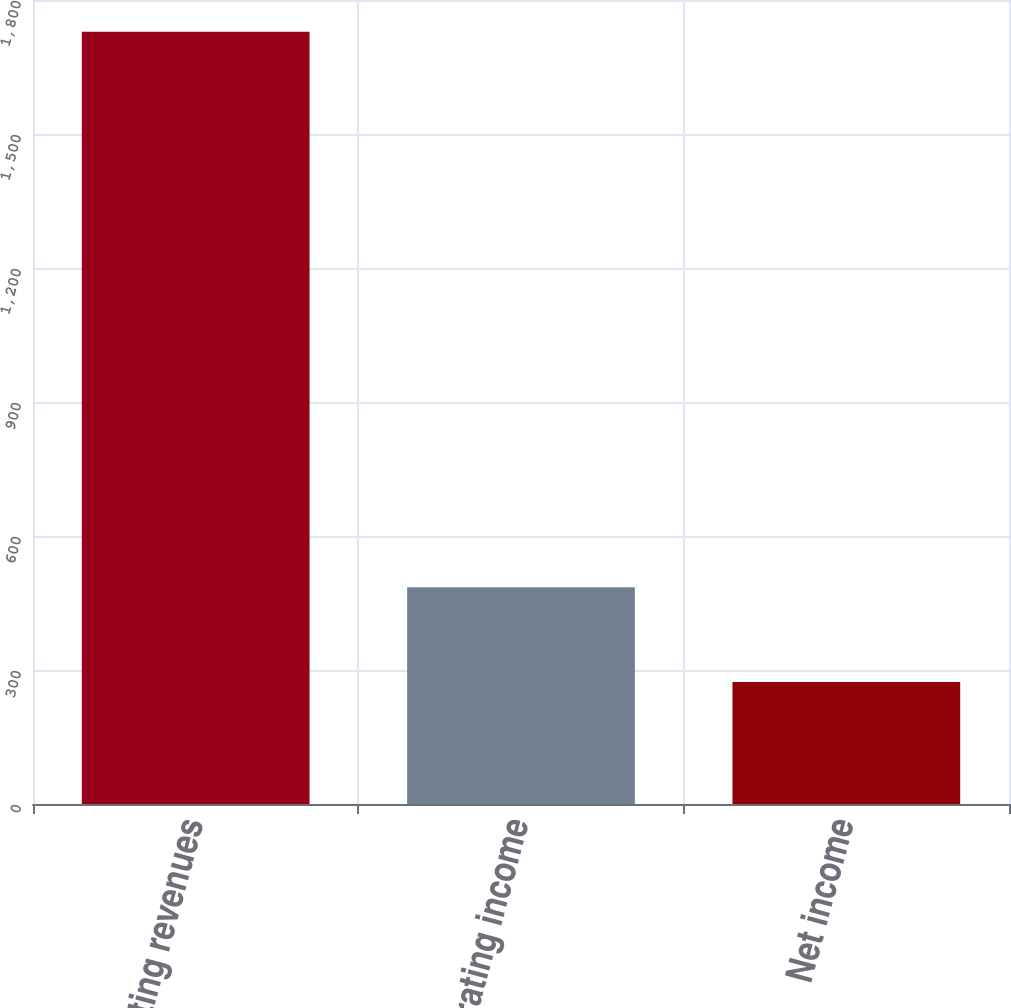Convert chart. <chart><loc_0><loc_0><loc_500><loc_500><bar_chart><fcel>Operating revenues<fcel>Operating income<fcel>Net income<nl><fcel>1729<fcel>485<fcel>273<nl></chart> 